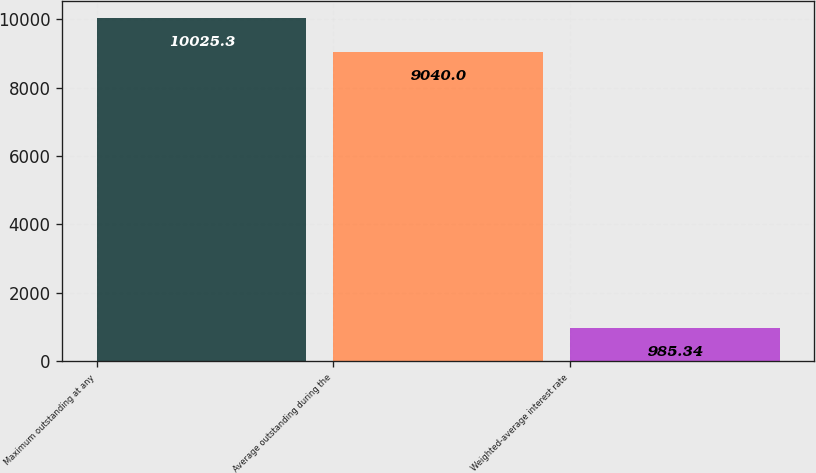Convert chart to OTSL. <chart><loc_0><loc_0><loc_500><loc_500><bar_chart><fcel>Maximum outstanding at any<fcel>Average outstanding during the<fcel>Weighted-average interest rate<nl><fcel>10025.3<fcel>9040<fcel>985.34<nl></chart> 